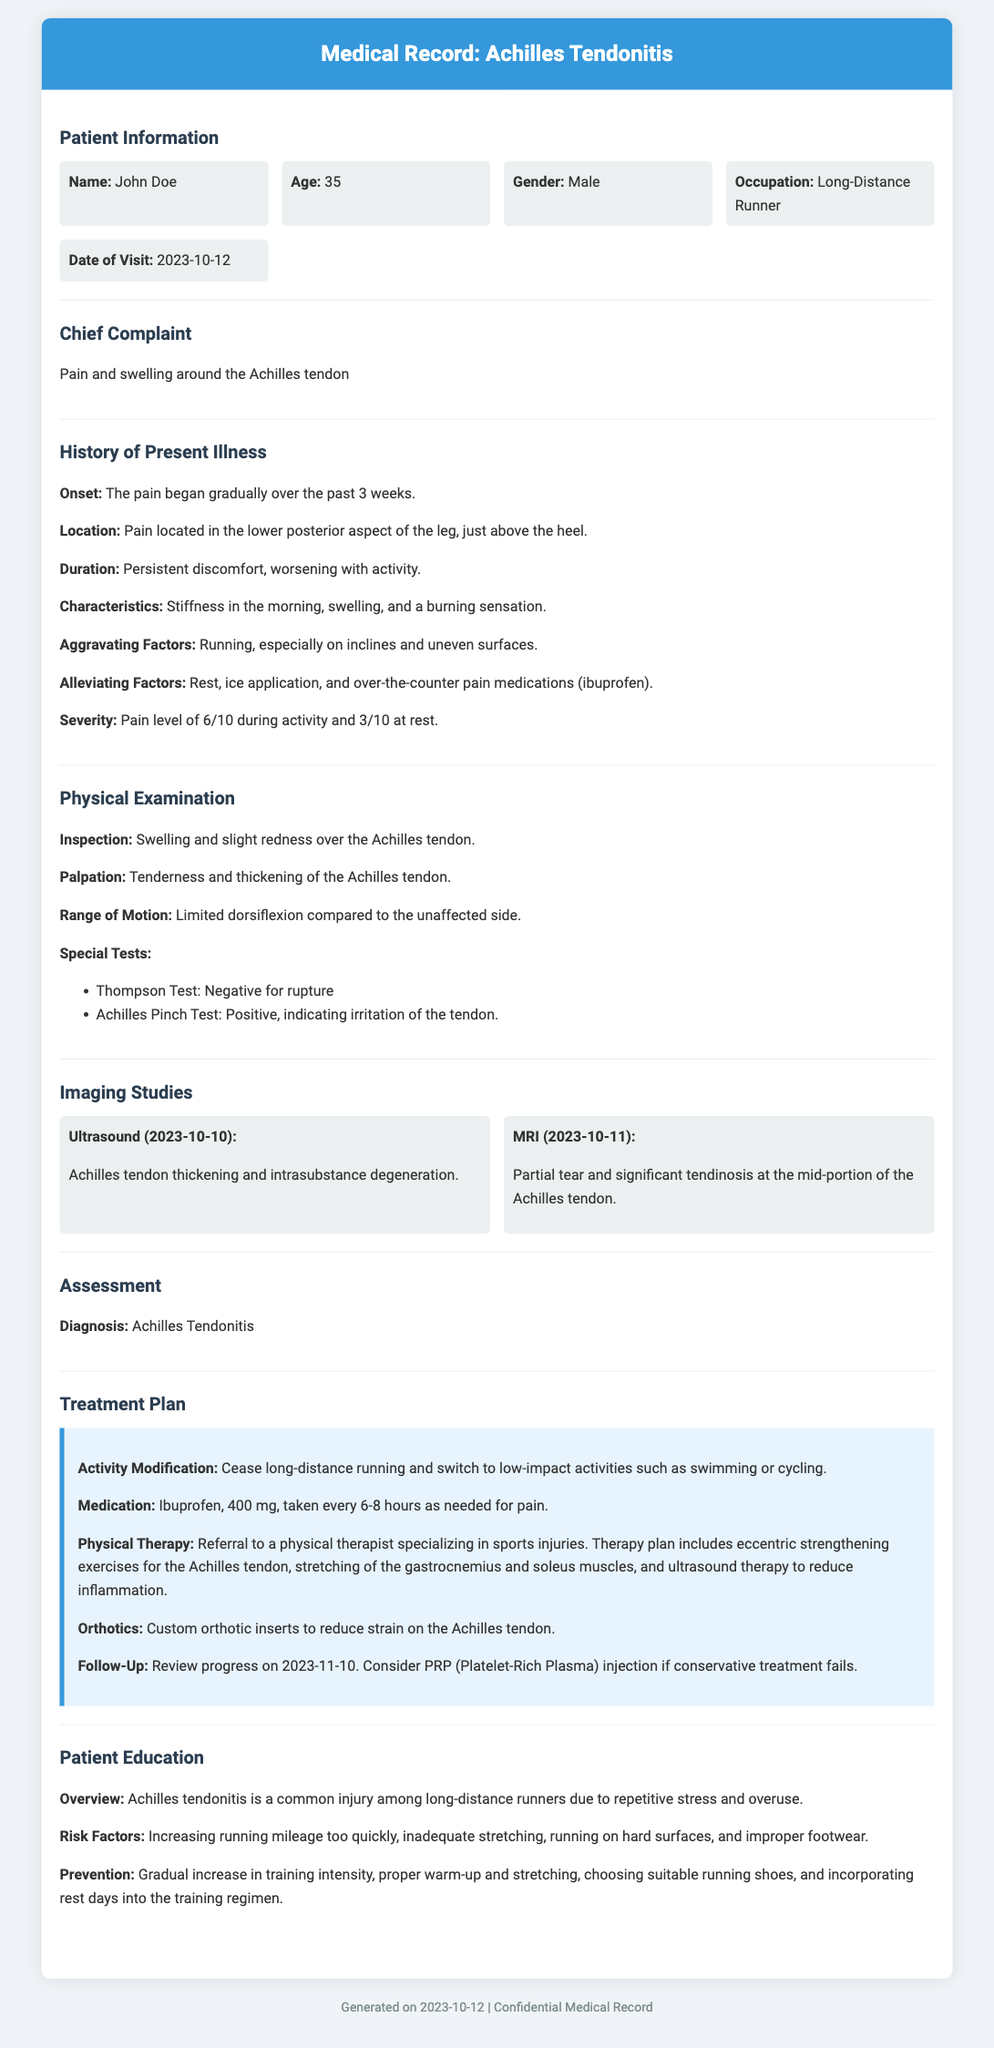What is the patient's name? The patient's name is mentioned in the patient information section of the document.
Answer: John Doe What is the date of the visit? The date of the visit is specified clearly in the patient information section.
Answer: 2023-10-12 What are the aggravating factors for the pain? The aggravating factors are listed in the history of present illness section.
Answer: Running, especially on inclines and uneven surfaces What is the diagnosis? The diagnosis is stated in the assessment section of the document.
Answer: Achilles Tendonitis What medication is recommended for pain? The recommended medication is noted in the treatment plan section.
Answer: Ibuprofen, 400 mg What does the physical therapy plan include? The physical therapy plan is described in the treatment plan section and includes specific interventions.
Answer: Eccentric strengthening exercises for the Achilles tendon What is the follow-up date? The follow-up date is provided in the treatment plan section.
Answer: 2023-11-10 What is a risk factor for Achilles tendonitis? Risk factors are listed in the patient education section.
Answer: Increasing running mileage too quickly What should be done to modify activity? Activity modification details are found in the treatment plan section.
Answer: Cease long-distance running and switch to low-impact activities 